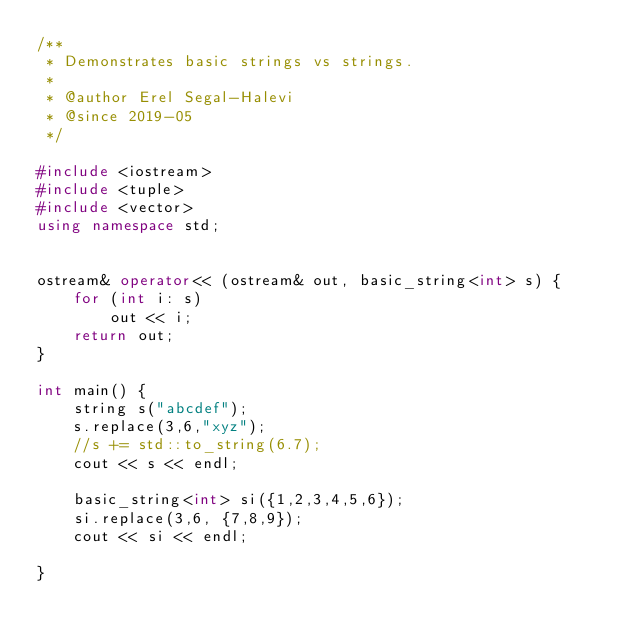Convert code to text. <code><loc_0><loc_0><loc_500><loc_500><_C++_>/**
 * Demonstrates basic strings vs strings.
 * 
 * @author Erel Segal-Halevi
 * @since 2019-05
 */

#include <iostream>
#include <tuple>
#include <vector>
using namespace std;


ostream& operator<< (ostream& out, basic_string<int> s) {
	for (int i: s)
		out << i;
	return out;
}

int main() {
	string s("abcdef");
	s.replace(3,6,"xyz");
	//s += std::to_string(6.7);
	cout << s << endl;

	basic_string<int> si({1,2,3,4,5,6});
	si.replace(3,6, {7,8,9});
	cout << si << endl;

}
</code> 